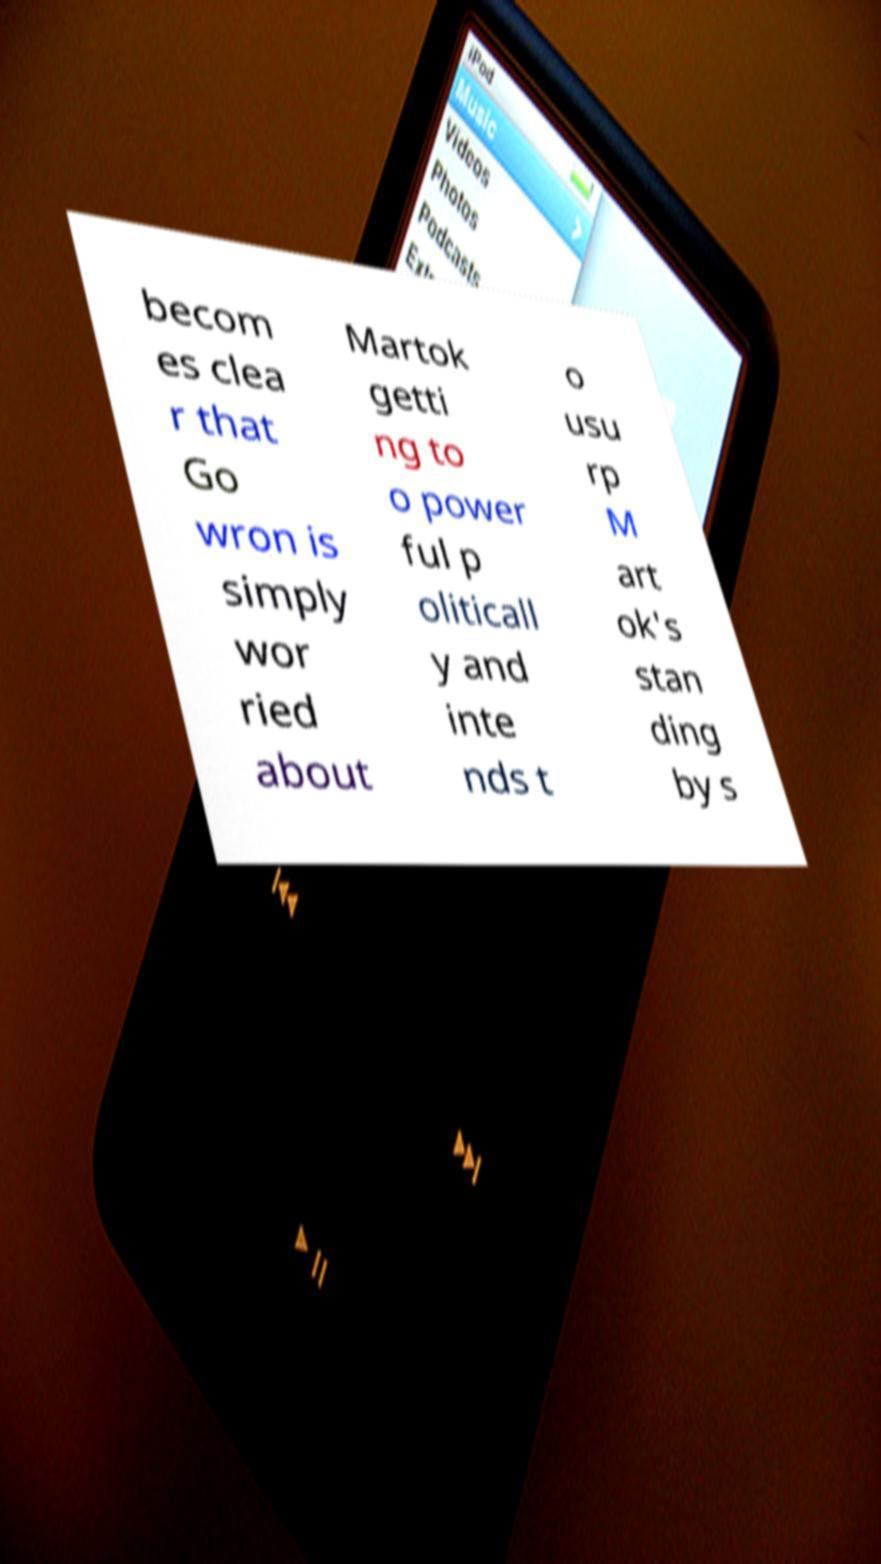Can you accurately transcribe the text from the provided image for me? becom es clea r that Go wron is simply wor ried about Martok getti ng to o power ful p oliticall y and inte nds t o usu rp M art ok's stan ding by s 